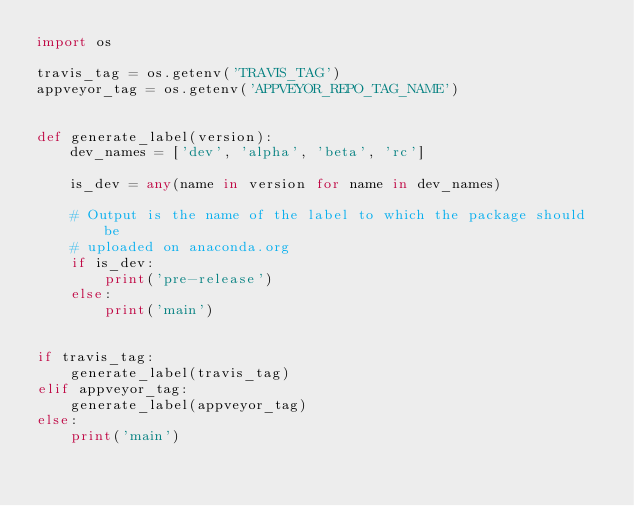<code> <loc_0><loc_0><loc_500><loc_500><_Python_>import os

travis_tag = os.getenv('TRAVIS_TAG')
appveyor_tag = os.getenv('APPVEYOR_REPO_TAG_NAME')


def generate_label(version):
    dev_names = ['dev', 'alpha', 'beta', 'rc']

    is_dev = any(name in version for name in dev_names)

    # Output is the name of the label to which the package should be
    # uploaded on anaconda.org
    if is_dev:
        print('pre-release')
    else:
        print('main')


if travis_tag:
    generate_label(travis_tag)
elif appveyor_tag:
    generate_label(appveyor_tag)
else:
    print('main')
</code> 